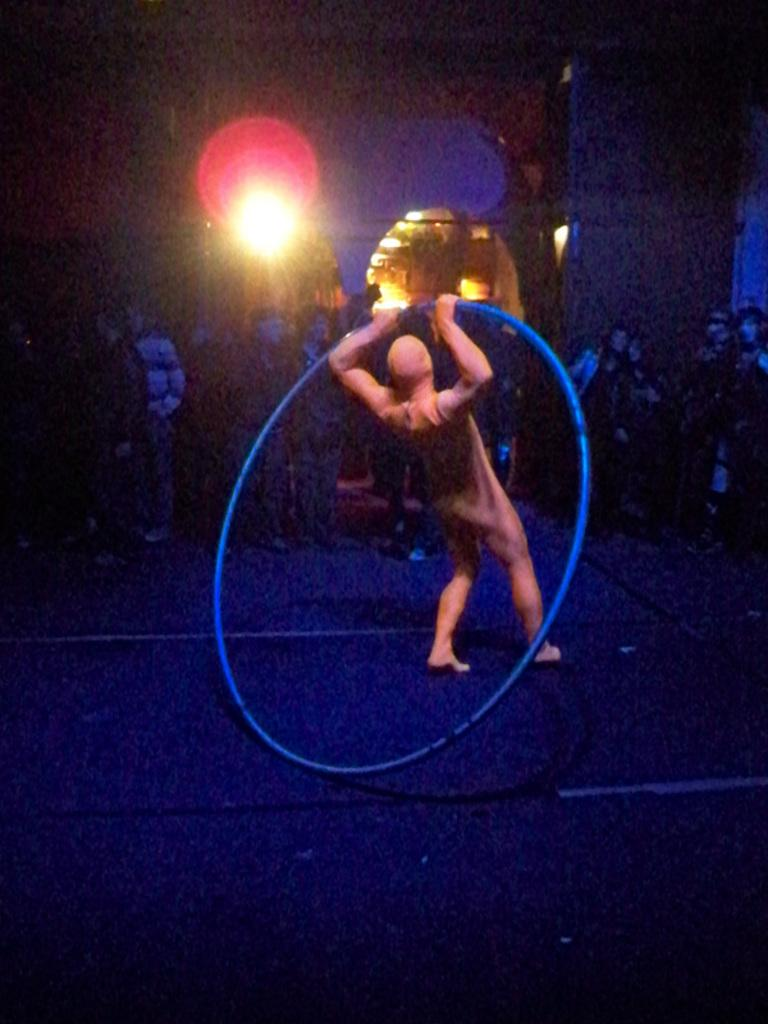What is the person in the image holding? The person in the image is holding a hoop. What can be seen behind the person holding the hoop? There are lights visible in the background of the image. What is the relationship between the person holding the hoop and the group of people in front of them? The provided facts do not give information about the relationship between the person holding the hoop and the group of people. Can you see a plane flying in the image? There is no plane visible in the image. Is there a girl in the image? The provided facts do not mention a girl in the image. 